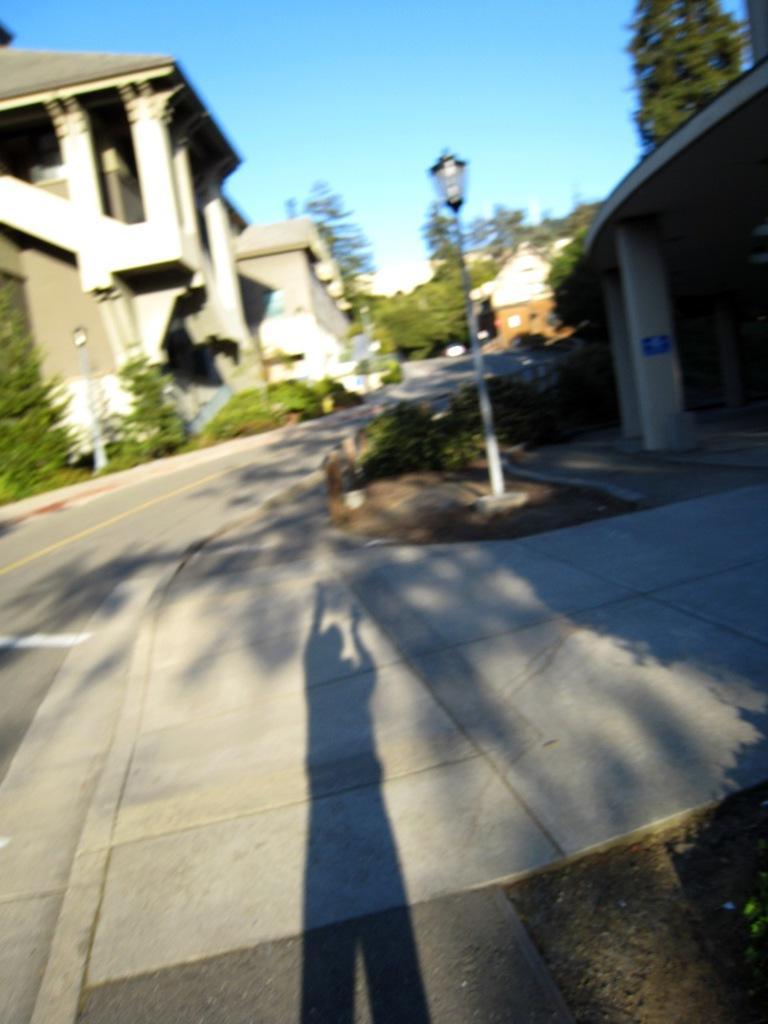Please provide a concise description of this image. In the image we can see this is a building, this is a light pole, grass, tree, pillar, sky, road and a shadow of a person. 